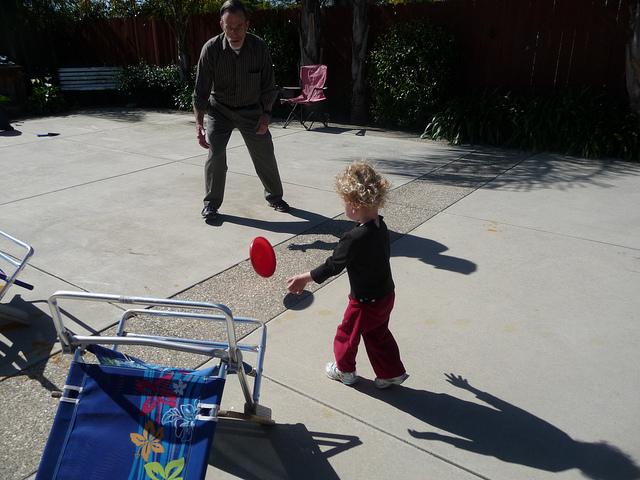What type of toy is being played with?
Quick response, please. Frisbee. What is upside down in this photo?
Answer briefly. Chair. Are these people high up in the sky?
Short answer required. No. Is it cold out?
Be succinct. No. Where is the child's shadow?
Give a very brief answer. Behind him. 